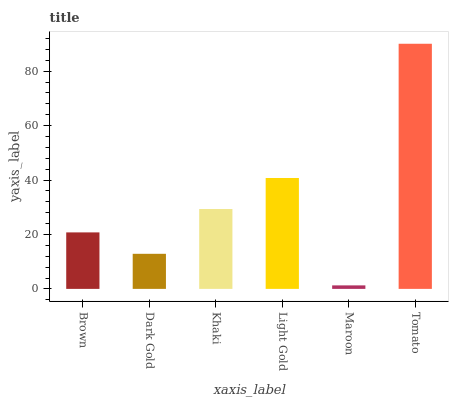Is Maroon the minimum?
Answer yes or no. Yes. Is Tomato the maximum?
Answer yes or no. Yes. Is Dark Gold the minimum?
Answer yes or no. No. Is Dark Gold the maximum?
Answer yes or no. No. Is Brown greater than Dark Gold?
Answer yes or no. Yes. Is Dark Gold less than Brown?
Answer yes or no. Yes. Is Dark Gold greater than Brown?
Answer yes or no. No. Is Brown less than Dark Gold?
Answer yes or no. No. Is Khaki the high median?
Answer yes or no. Yes. Is Brown the low median?
Answer yes or no. Yes. Is Light Gold the high median?
Answer yes or no. No. Is Dark Gold the low median?
Answer yes or no. No. 